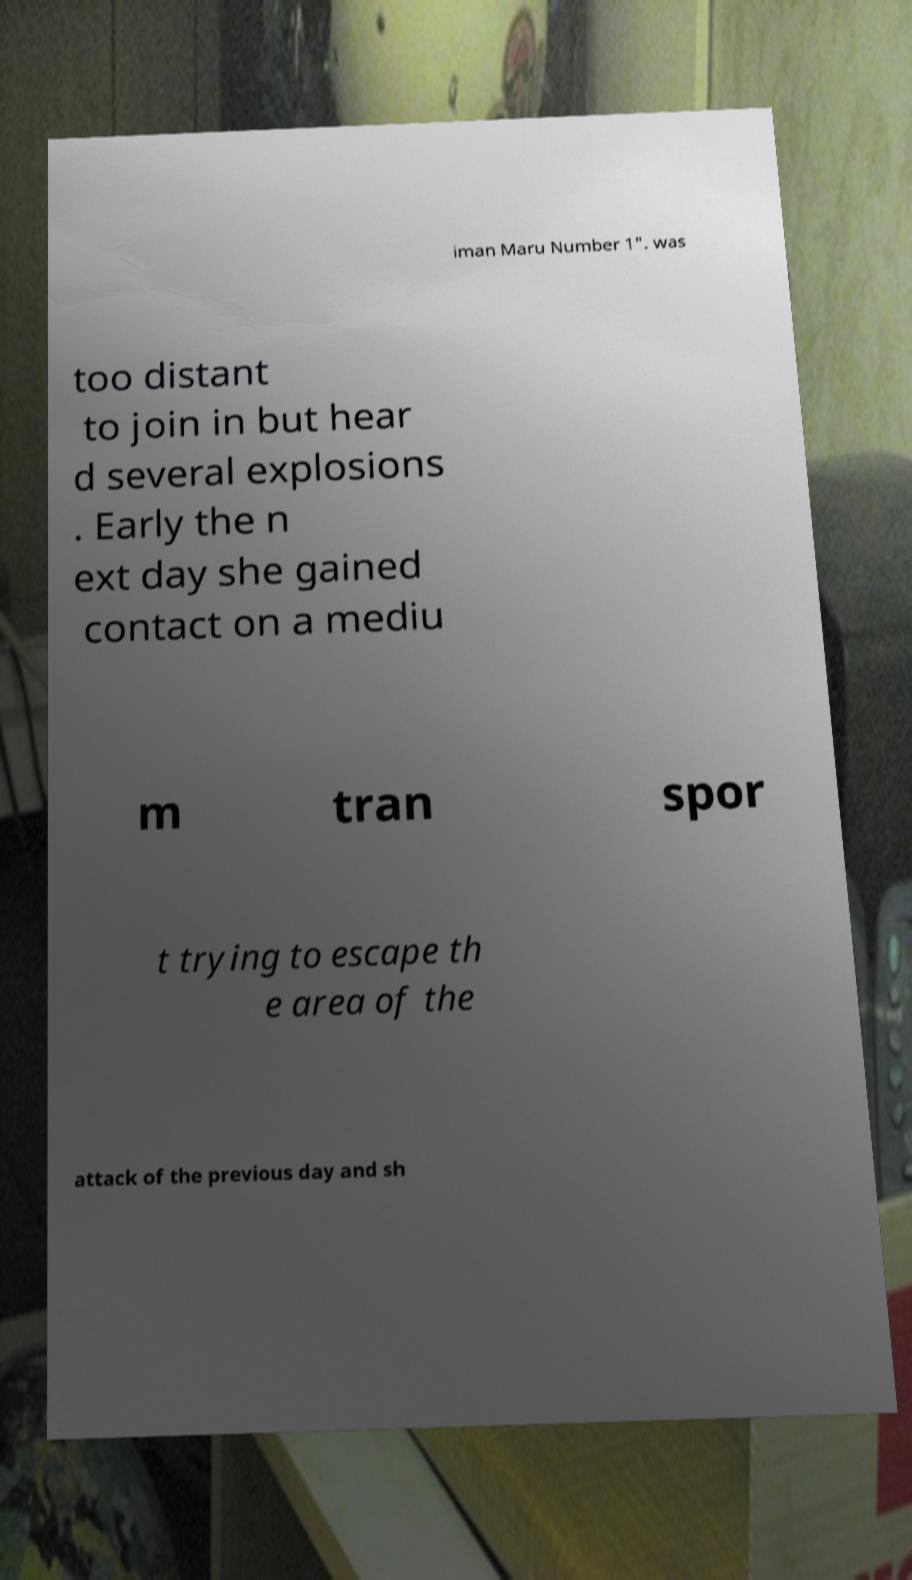Can you read and provide the text displayed in the image?This photo seems to have some interesting text. Can you extract and type it out for me? iman Maru Number 1". was too distant to join in but hear d several explosions . Early the n ext day she gained contact on a mediu m tran spor t trying to escape th e area of the attack of the previous day and sh 